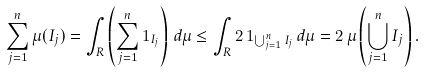Convert formula to latex. <formula><loc_0><loc_0><loc_500><loc_500>\sum _ { j = 1 } ^ { n } \mu ( I _ { j } ) = \int _ { R } \left ( \sum _ { j = 1 } ^ { n } { 1 } _ { I _ { j } } \right ) \, d \mu \leq \int _ { R } 2 \, { 1 } _ { \bigcup _ { j = 1 } ^ { n } I _ { j } } \, d \mu = 2 \, \mu \left ( \bigcup _ { j = 1 } ^ { n } I _ { j } \right ) .</formula> 